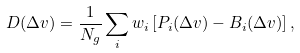Convert formula to latex. <formula><loc_0><loc_0><loc_500><loc_500>D ( \Delta v ) = \frac { 1 } { N _ { g } } \sum _ { i } w _ { i } \left [ P _ { i } ( \Delta v ) - B _ { i } ( \Delta v ) \right ] ,</formula> 